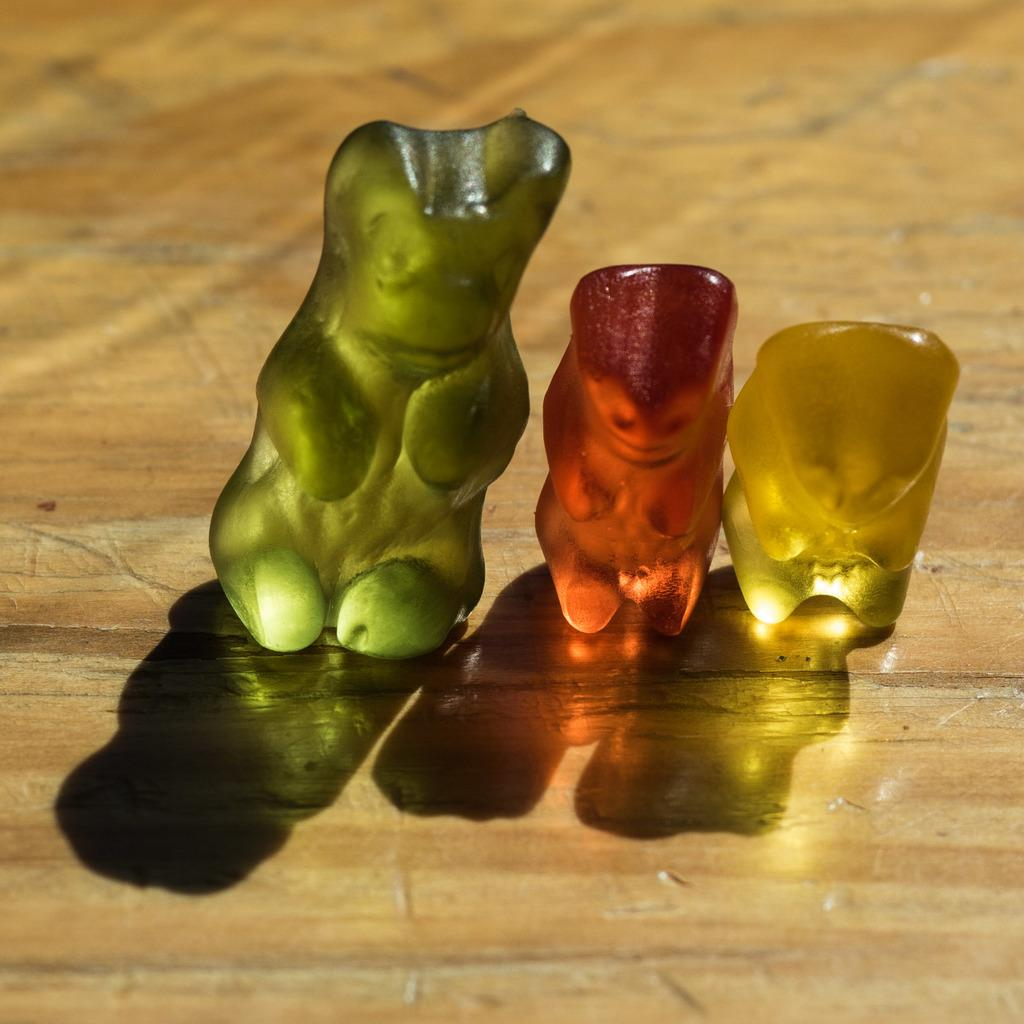What type of objects are in the image? There are dolls in the image. How many different colors can be seen among the dolls? The dolls have different colors. What surface are the dolls placed on? The dolls are on a wooden board. Where can the store selling these dolls be found in the image? There is no store present in the image; it only shows dolls on a wooden board. How many cherries are on the dolls in the image? There are no cherries present in the image; it only shows dolls on a wooden board. 